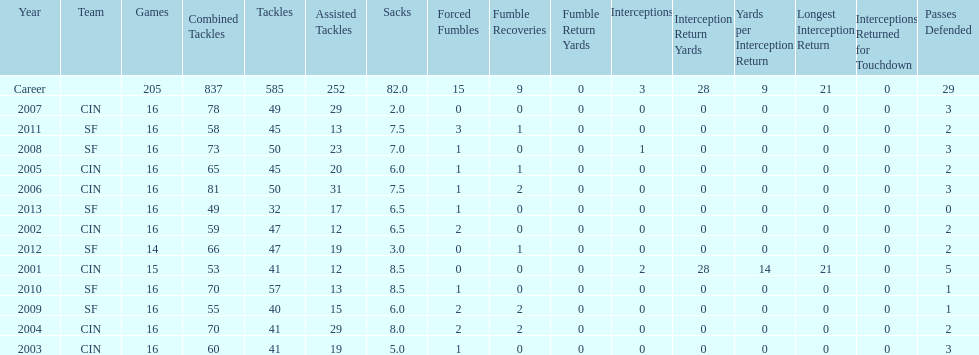How many consecutive years were there 20 or more assisted tackles? 5. 